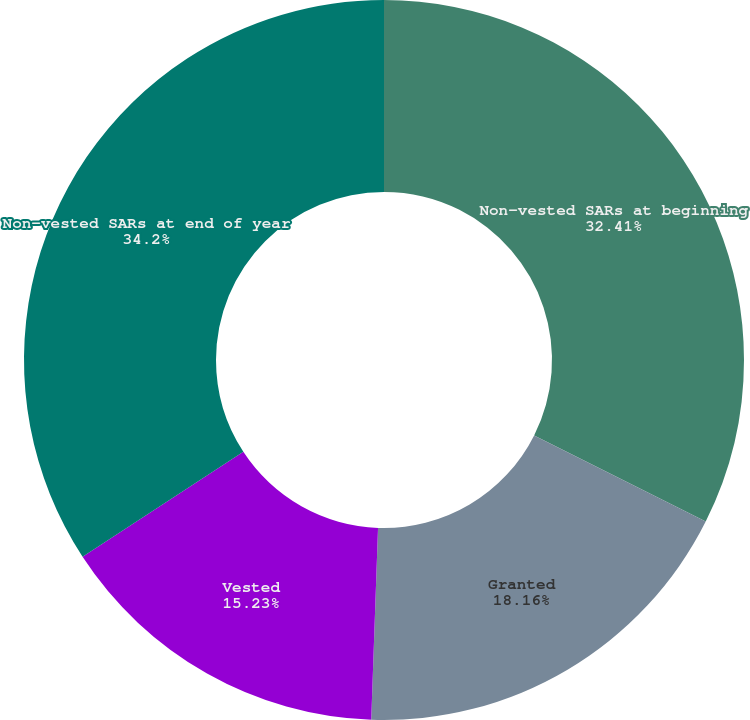<chart> <loc_0><loc_0><loc_500><loc_500><pie_chart><fcel>Non-vested SARs at beginning<fcel>Granted<fcel>Vested<fcel>Non-vested SARs at end of year<nl><fcel>32.41%<fcel>18.16%<fcel>15.23%<fcel>34.21%<nl></chart> 